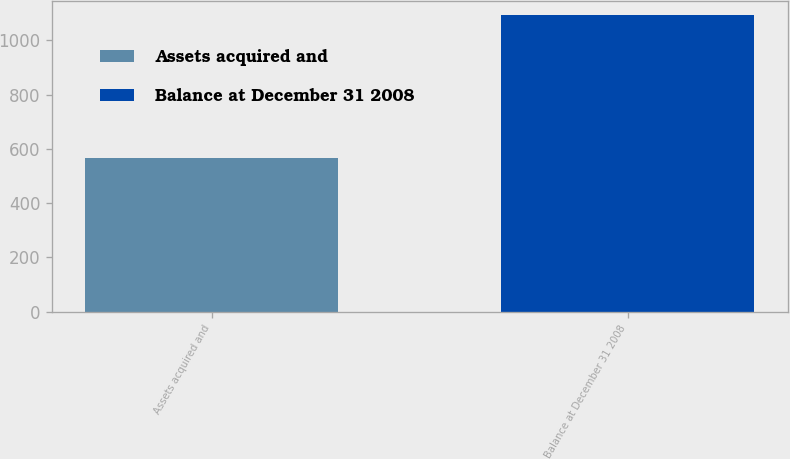Convert chart to OTSL. <chart><loc_0><loc_0><loc_500><loc_500><bar_chart><fcel>Assets acquired and<fcel>Balance at December 31 2008<nl><fcel>567<fcel>1091<nl></chart> 